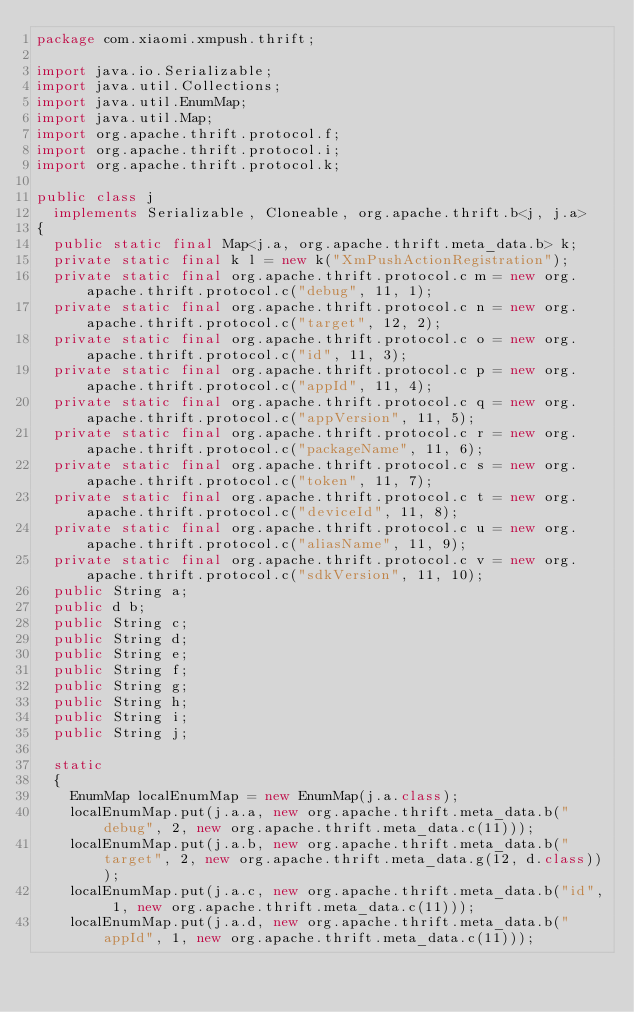Convert code to text. <code><loc_0><loc_0><loc_500><loc_500><_Java_>package com.xiaomi.xmpush.thrift;

import java.io.Serializable;
import java.util.Collections;
import java.util.EnumMap;
import java.util.Map;
import org.apache.thrift.protocol.f;
import org.apache.thrift.protocol.i;
import org.apache.thrift.protocol.k;

public class j
  implements Serializable, Cloneable, org.apache.thrift.b<j, j.a>
{
  public static final Map<j.a, org.apache.thrift.meta_data.b> k;
  private static final k l = new k("XmPushActionRegistration");
  private static final org.apache.thrift.protocol.c m = new org.apache.thrift.protocol.c("debug", 11, 1);
  private static final org.apache.thrift.protocol.c n = new org.apache.thrift.protocol.c("target", 12, 2);
  private static final org.apache.thrift.protocol.c o = new org.apache.thrift.protocol.c("id", 11, 3);
  private static final org.apache.thrift.protocol.c p = new org.apache.thrift.protocol.c("appId", 11, 4);
  private static final org.apache.thrift.protocol.c q = new org.apache.thrift.protocol.c("appVersion", 11, 5);
  private static final org.apache.thrift.protocol.c r = new org.apache.thrift.protocol.c("packageName", 11, 6);
  private static final org.apache.thrift.protocol.c s = new org.apache.thrift.protocol.c("token", 11, 7);
  private static final org.apache.thrift.protocol.c t = new org.apache.thrift.protocol.c("deviceId", 11, 8);
  private static final org.apache.thrift.protocol.c u = new org.apache.thrift.protocol.c("aliasName", 11, 9);
  private static final org.apache.thrift.protocol.c v = new org.apache.thrift.protocol.c("sdkVersion", 11, 10);
  public String a;
  public d b;
  public String c;
  public String d;
  public String e;
  public String f;
  public String g;
  public String h;
  public String i;
  public String j;

  static
  {
    EnumMap localEnumMap = new EnumMap(j.a.class);
    localEnumMap.put(j.a.a, new org.apache.thrift.meta_data.b("debug", 2, new org.apache.thrift.meta_data.c(11)));
    localEnumMap.put(j.a.b, new org.apache.thrift.meta_data.b("target", 2, new org.apache.thrift.meta_data.g(12, d.class)));
    localEnumMap.put(j.a.c, new org.apache.thrift.meta_data.b("id", 1, new org.apache.thrift.meta_data.c(11)));
    localEnumMap.put(j.a.d, new org.apache.thrift.meta_data.b("appId", 1, new org.apache.thrift.meta_data.c(11)));</code> 